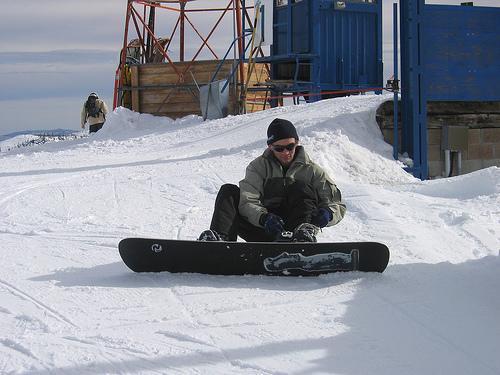How many people are sitting?
Give a very brief answer. 1. 